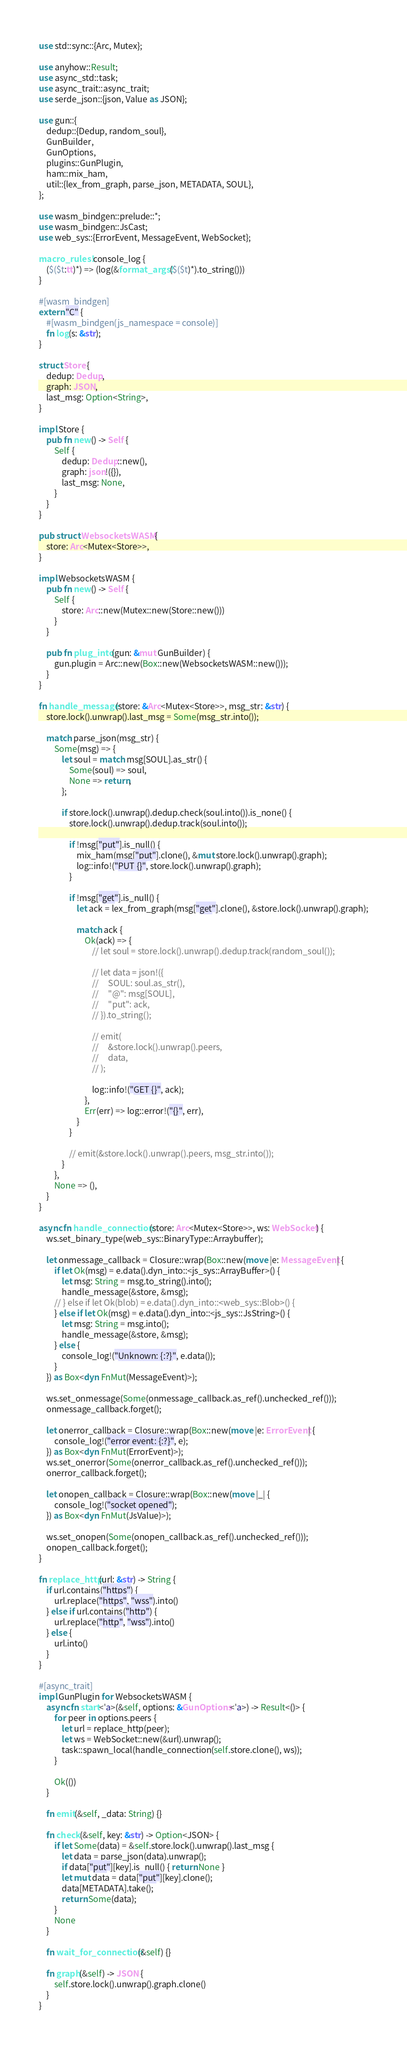Convert code to text. <code><loc_0><loc_0><loc_500><loc_500><_Rust_>use std::sync::{Arc, Mutex};

use anyhow::Result;
use async_std::task;
use async_trait::async_trait;
use serde_json::{json, Value as JSON};

use gun::{
	dedup::{Dedup, random_soul},
	GunBuilder,
    GunOptions,
    plugins::GunPlugin,
	ham::mix_ham,
	util::{lex_from_graph, parse_json, METADATA, SOUL},
};

use wasm_bindgen::prelude::*;
use wasm_bindgen::JsCast;
use web_sys::{ErrorEvent, MessageEvent, WebSocket};

macro_rules! console_log {
    ($($t:tt)*) => (log(&format_args!($($t)*).to_string()))
}

#[wasm_bindgen]
extern "C" {
    #[wasm_bindgen(js_namespace = console)]
    fn log(s: &str);
}

struct Store {
	dedup: Dedup,
    graph: JSON,
    last_msg: Option<String>,
}

impl Store {
	pub fn new() -> Self {
		Self {
			dedup: Dedup::new(),
            graph: json!({}),
            last_msg: None,
		}
	}
}

pub struct WebsocketsWASM {
    store: Arc<Mutex<Store>>,
}

impl WebsocketsWASM {
	pub fn new() -> Self {
		Self {
			store: Arc::new(Mutex::new(Store::new()))
		}
	}

	pub fn plug_into(gun: &mut GunBuilder) {
		gun.plugin = Arc::new(Box::new(WebsocketsWASM::new()));
	}
}

fn handle_message(store: &Arc<Mutex<Store>>, msg_str: &str) {
    store.lock().unwrap().last_msg = Some(msg_str.into());

    match parse_json(msg_str) {
        Some(msg) => {
            let soul = match msg[SOUL].as_str() {
                Some(soul) => soul,
                None => return,
            };

            if store.lock().unwrap().dedup.check(soul.into()).is_none() {
                store.lock().unwrap().dedup.track(soul.into());

                if !msg["put"].is_null() {
                    mix_ham(msg["put"].clone(), &mut store.lock().unwrap().graph);
                    log::info!("PUT {}", store.lock().unwrap().graph);
                }

                if !msg["get"].is_null() {
                    let ack = lex_from_graph(msg["get"].clone(), &store.lock().unwrap().graph);

                    match ack {
                        Ok(ack) => {
                            // let soul = store.lock().unwrap().dedup.track(random_soul());

                            // let data = json!({
                            //     SOUL: soul.as_str(),
                            //     "@": msg[SOUL],
                            //     "put": ack,
                            // }).to_string();

                            // emit(
                            //     &store.lock().unwrap().peers,
                            //     data,
                            // );

                            log::info!("GET {}", ack);
                        },
                        Err(err) => log::error!("{}", err),
                    }
                }
                
                // emit(&store.lock().unwrap().peers, msg_str.into());
            }
        },
        None => (),
    }
}

async fn handle_connection(store: Arc<Mutex<Store>>, ws: WebSocket) {
	ws.set_binary_type(web_sys::BinaryType::Arraybuffer);

    let onmessage_callback = Closure::wrap(Box::new(move |e: MessageEvent| {
        if let Ok(msg) = e.data().dyn_into::<js_sys::ArrayBuffer>() {
            let msg: String = msg.to_string().into();
            handle_message(&store, &msg);
        // } else if let Ok(blob) = e.data().dyn_into::<web_sys::Blob>() {
        } else if let Ok(msg) = e.data().dyn_into::<js_sys::JsString>() {
        	let msg: String = msg.into();
            handle_message(&store, &msg);
        } else {
            console_log!("Unknown: {:?}", e.data());
        }
    }) as Box<dyn FnMut(MessageEvent)>);

    ws.set_onmessage(Some(onmessage_callback.as_ref().unchecked_ref()));
    onmessage_callback.forget();

    let onerror_callback = Closure::wrap(Box::new(move |e: ErrorEvent| {
        console_log!("error event: {:?}", e);
    }) as Box<dyn FnMut(ErrorEvent)>);
    ws.set_onerror(Some(onerror_callback.as_ref().unchecked_ref()));
    onerror_callback.forget();

    let onopen_callback = Closure::wrap(Box::new(move |_| {
        console_log!("socket opened");
    }) as Box<dyn FnMut(JsValue)>);

    ws.set_onopen(Some(onopen_callback.as_ref().unchecked_ref()));
    onopen_callback.forget();
}

fn replace_http(url: &str) -> String {
    if url.contains("https") {
        url.replace("https", "wss").into()
    } else if url.contains("http") {
        url.replace("http", "wss").into()
    } else {
        url.into()
    }
}

#[async_trait]
impl GunPlugin for WebsocketsWASM {
	async fn start<'a>(&self, options: &GunOptions<'a>) -> Result<()> {
		for peer in options.peers {
            let url = replace_http(peer);
    		let ws = WebSocket::new(&url).unwrap();
            task::spawn_local(handle_connection(self.store.clone(), ws));
        }

		Ok(())
	}

	fn emit(&self, _data: String) {}

	fn check(&self, key: &str) -> Option<JSON> {
		if let Some(data) = &self.store.lock().unwrap().last_msg {
            let data = parse_json(data).unwrap();
            if data["put"][key].is_null() { return None }
            let mut data = data["put"][key].clone();
            data[METADATA].take();
            return Some(data);
        }
        None
	}

	fn wait_for_connection(&self) {}

	fn graph(&self) -> JSON {
		self.store.lock().unwrap().graph.clone()
	}
}
</code> 